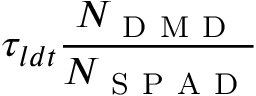<formula> <loc_0><loc_0><loc_500><loc_500>\tau _ { l d t } \frac { N _ { D M D } } { N _ { S P A D } }</formula> 